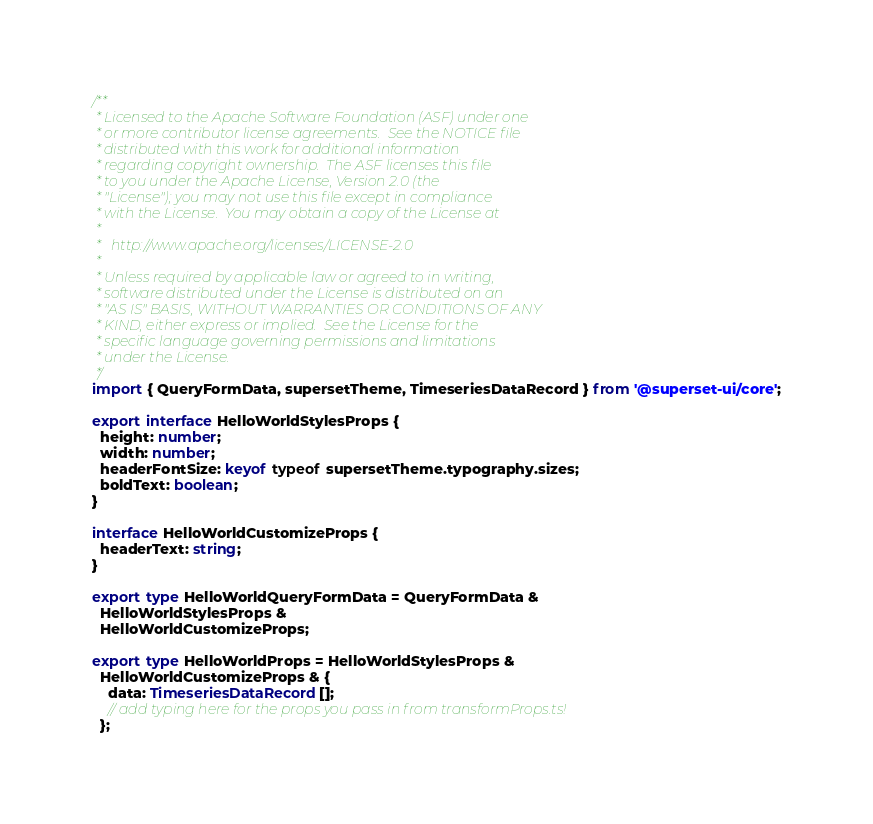<code> <loc_0><loc_0><loc_500><loc_500><_TypeScript_>/**
 * Licensed to the Apache Software Foundation (ASF) under one
 * or more contributor license agreements.  See the NOTICE file
 * distributed with this work for additional information
 * regarding copyright ownership.  The ASF licenses this file
 * to you under the Apache License, Version 2.0 (the
 * "License"); you may not use this file except in compliance
 * with the License.  You may obtain a copy of the License at
 *
 *   http://www.apache.org/licenses/LICENSE-2.0
 *
 * Unless required by applicable law or agreed to in writing,
 * software distributed under the License is distributed on an
 * "AS IS" BASIS, WITHOUT WARRANTIES OR CONDITIONS OF ANY
 * KIND, either express or implied.  See the License for the
 * specific language governing permissions and limitations
 * under the License.
 */
import { QueryFormData, supersetTheme, TimeseriesDataRecord } from '@superset-ui/core';

export interface HelloWorldStylesProps {
  height: number;
  width: number;
  headerFontSize: keyof typeof supersetTheme.typography.sizes;
  boldText: boolean;
}

interface HelloWorldCustomizeProps {
  headerText: string;
}

export type HelloWorldQueryFormData = QueryFormData &
  HelloWorldStylesProps &
  HelloWorldCustomizeProps;

export type HelloWorldProps = HelloWorldStylesProps &
  HelloWorldCustomizeProps & {
    data: TimeseriesDataRecord[];
    // add typing here for the props you pass in from transformProps.ts!
  };
</code> 